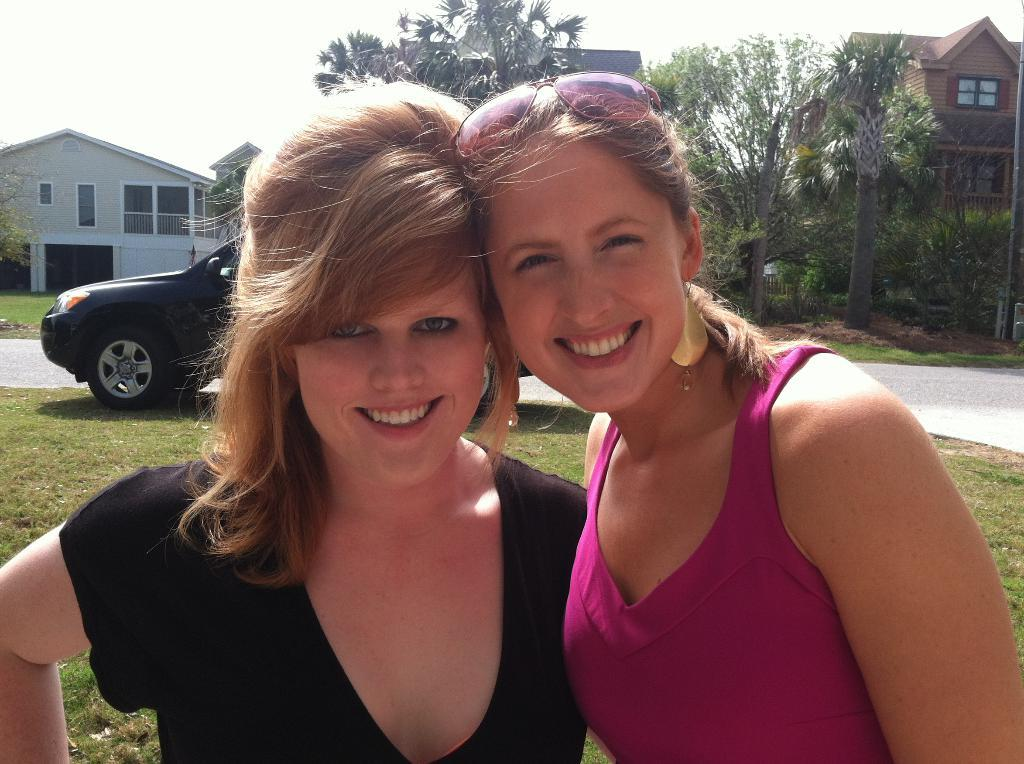How many women are in the image? There are two women in the image. What expression do the women have? The women are smiling. What can be seen in the background of the image? There is a vehicle, grass, houses, trees, and the sky visible in the background of the image. What type of jewel is being studied by the women in the image? There is no jewel present in the image, and the women are not engaged in any scientific activity. 